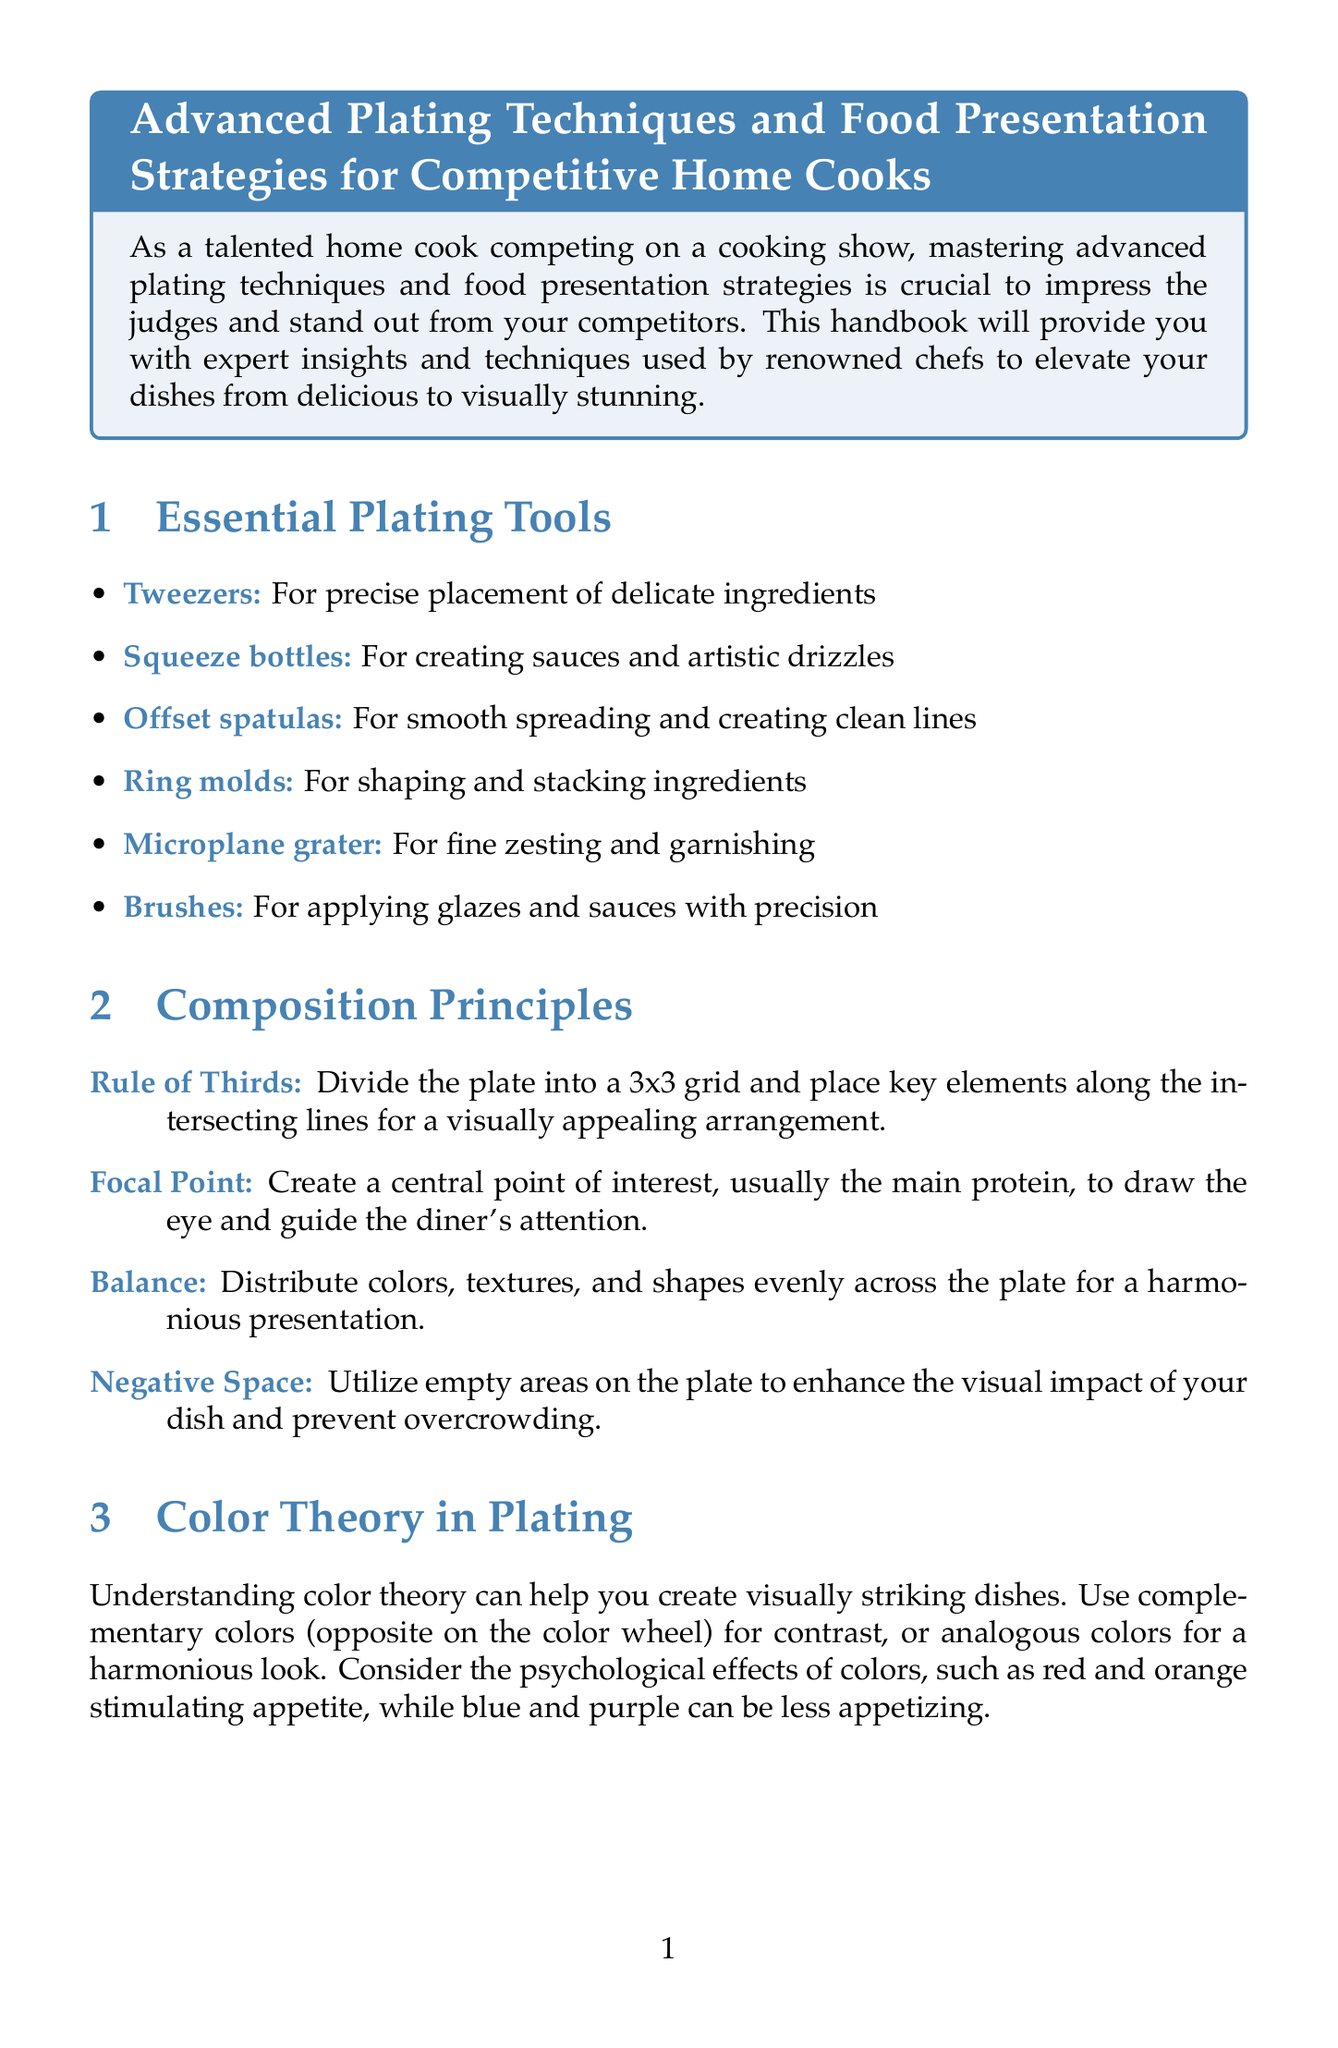What is the title of the handbook? The title is found at the beginning of the document and summarizes its content focused on advanced plating and presentation techniques.
Answer: Advanced Plating Techniques and Food Presentation Strategies for Competitive Home Cooks How many essential plating tools are listed? The document lists the essential plating tools in a section dedicated to them. There are six tools mentioned.
Answer: Six What is the Rule of Thirds? This technique is described in the section on Composition Principles, specifying how to arrange elements on the plate.
Answer: Divide the plate into a 3x3 grid What technique uses two spoons to create oval shapes? This technique is mentioned under Texture and Height, showcasing a method for presenting soft ingredients elegantly.
Answer: Quenelles Which cuisine emphasizes symmetry and precision? This information is found in the Cuisine-Specific Plating Styles section, where various styles are summarized.
Answer: French Cuisine What tips are provided for photography? The document offers practical advice in a section dedicated to showcasing culinary creations through photography.
Answer: Use natural light whenever possible What is recommended for utilizing empty areas on the plate? The concept is explained under Composition Principles related to enhancing dish visual impact.
Answer: Negative Space How many plating styles are mentioned in the document? The document outlines various cuisine-specific styles to enhance understanding of plating diversity. There are three styles mentioned.
Answer: Three 